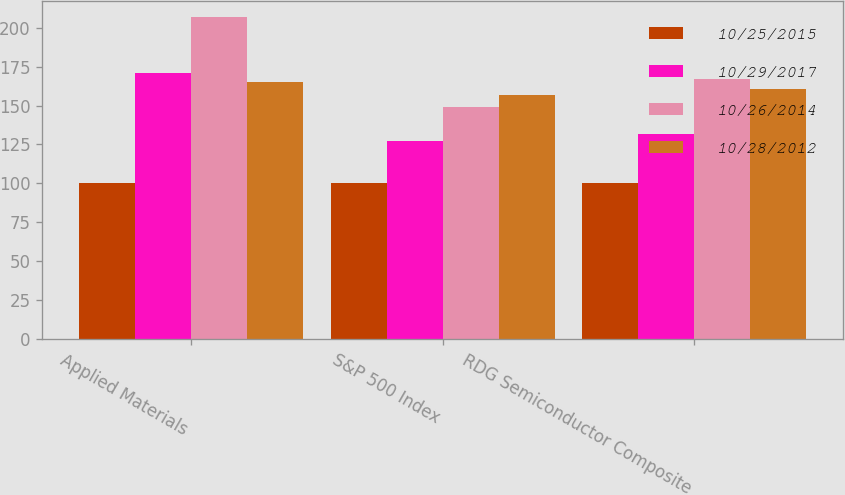<chart> <loc_0><loc_0><loc_500><loc_500><stacked_bar_chart><ecel><fcel>Applied Materials<fcel>S&P 500 Index<fcel>RDG Semiconductor Composite<nl><fcel>10/25/2015<fcel>100<fcel>100<fcel>100<nl><fcel>10/29/2017<fcel>171.03<fcel>127.18<fcel>131.94<nl><fcel>10/26/2014<fcel>207.01<fcel>149.14<fcel>167.25<nl><fcel>10/28/2012<fcel>165.34<fcel>156.89<fcel>160.8<nl></chart> 